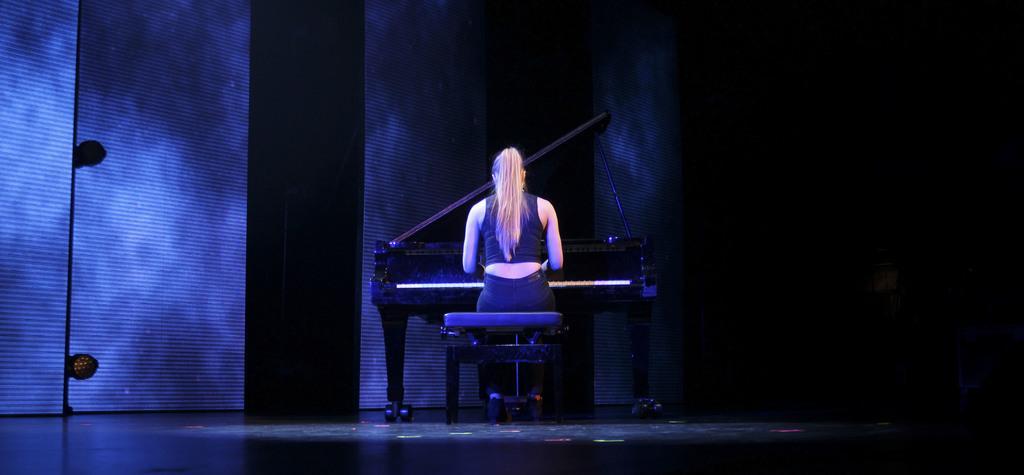In one or two sentences, can you explain what this image depicts? Background portion of the picture is dark. In this picture we can see a woman sitting on a stool. We can see a table and musical instrument. At the bottom portion of the picture we can see the platform. We can see few objects. 